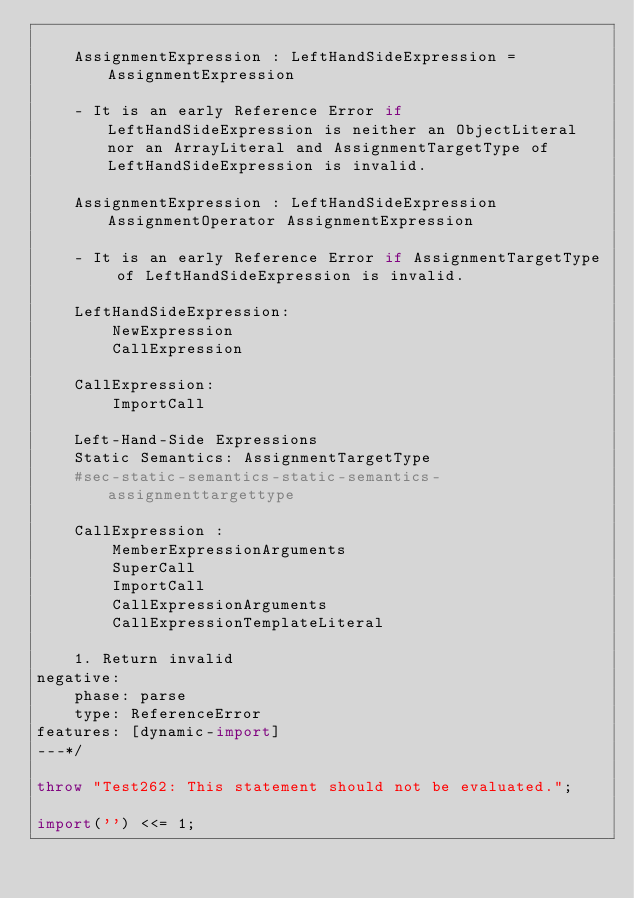Convert code to text. <code><loc_0><loc_0><loc_500><loc_500><_JavaScript_>
    AssignmentExpression : LeftHandSideExpression = AssignmentExpression

    - It is an early Reference Error if LeftHandSideExpression is neither an ObjectLiteral nor an ArrayLiteral and AssignmentTargetType of LeftHandSideExpression is invalid.

    AssignmentExpression : LeftHandSideExpression AssignmentOperator AssignmentExpression

    - It is an early Reference Error if AssignmentTargetType of LeftHandSideExpression is invalid.

    LeftHandSideExpression:
        NewExpression
        CallExpression

    CallExpression:
        ImportCall

    Left-Hand-Side Expressions
    Static Semantics: AssignmentTargetType
    #sec-static-semantics-static-semantics-assignmenttargettype

    CallExpression :
        MemberExpressionArguments
        SuperCall
        ImportCall
        CallExpressionArguments
        CallExpressionTemplateLiteral

    1. Return invalid
negative:
    phase: parse
    type: ReferenceError
features: [dynamic-import]
---*/

throw "Test262: This statement should not be evaluated.";

import('') <<= 1;
</code> 